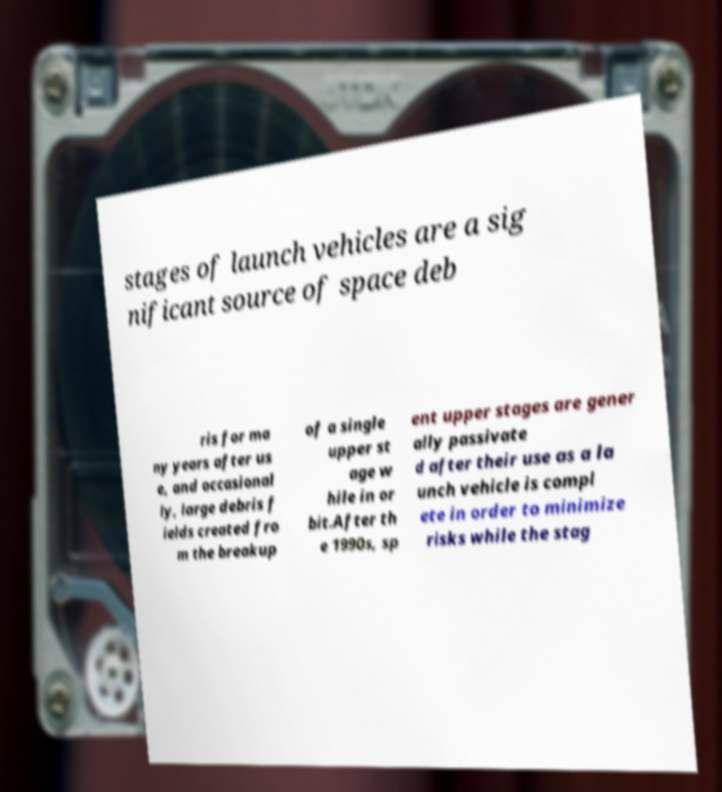Could you extract and type out the text from this image? stages of launch vehicles are a sig nificant source of space deb ris for ma ny years after us e, and occasional ly, large debris f ields created fro m the breakup of a single upper st age w hile in or bit.After th e 1990s, sp ent upper stages are gener ally passivate d after their use as a la unch vehicle is compl ete in order to minimize risks while the stag 